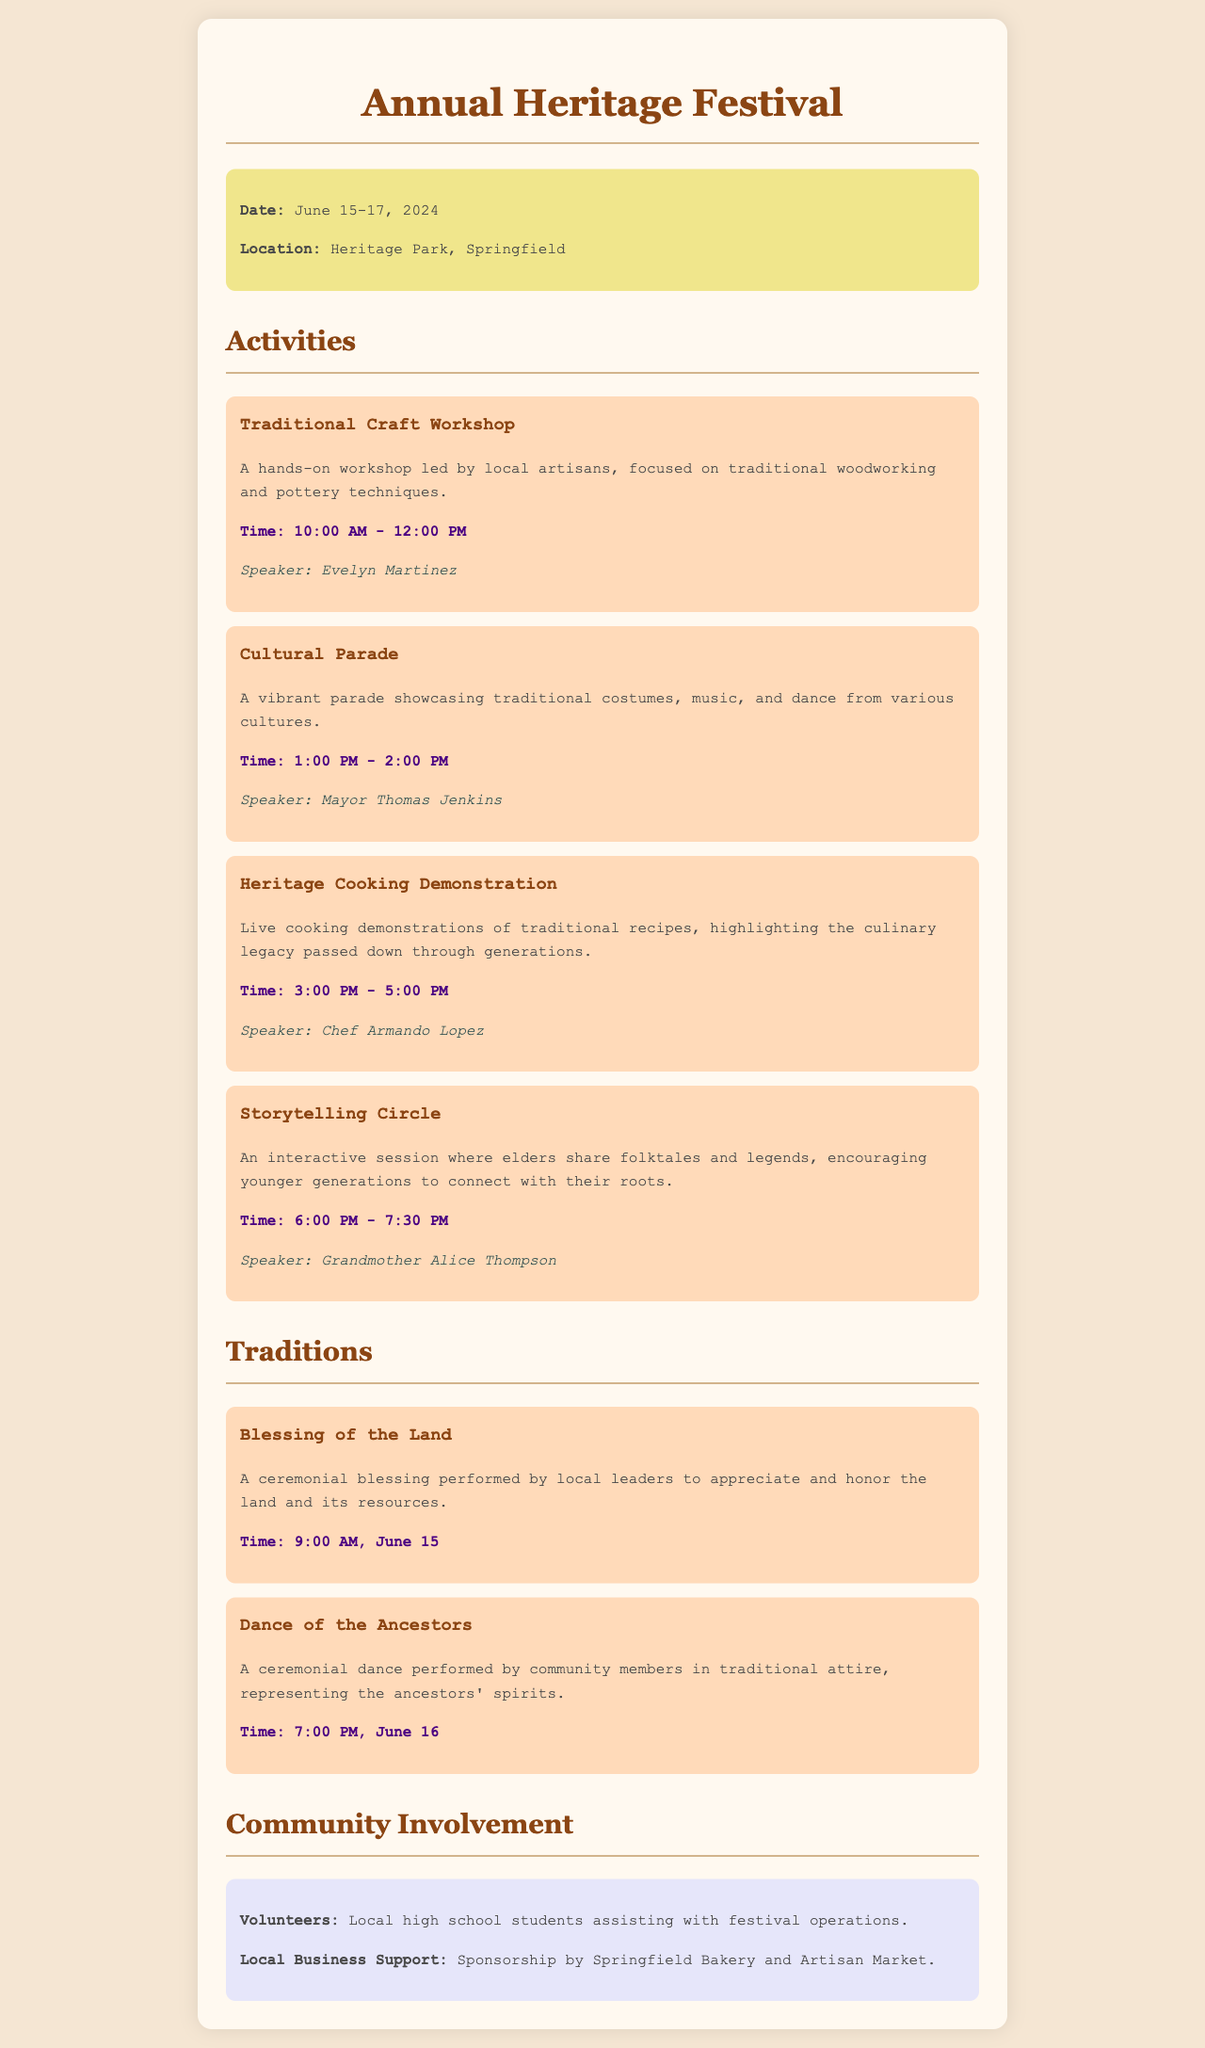what are the dates of the festival? The dates of the festival are mentioned in the document, which states it runs from June 15 to June 17, 2024.
Answer: June 15-17, 2024 where is the festival taking place? The location of the festival is specified in the event information section, stating it will be at Heritage Park, Springfield.
Answer: Heritage Park, Springfield who is leading the Traditional Craft Workshop? The document lists the speaker for the Traditional Craft Workshop as Evelyn Martinez.
Answer: Evelyn Martinez what time is the Cultural Parade scheduled? The document clearly states the time for the Cultural Parade is from 1:00 PM to 2:00 PM.
Answer: 1:00 PM - 2:00 PM what is the purpose of the Blessing of the Land? The Blessing of the Land is a ceremonial act to appreciate and honor the land and its resources, as described in the traditions section.
Answer: Appreciate and honor the land who assists with the festival operations? The document mentions that local high school students are volunteering to assist with festival operations.
Answer: Local high school students what traditional activity takes place at 7:00 PM on June 16? The Dance of the Ancestors is scheduled for 7:00 PM on June 16, as detailed in the traditions section.
Answer: Dance of the Ancestors what type of food demonstration is featured at the festival? The document highlights the Heritage Cooking Demonstration as a significant food-related activity during the festival.
Answer: Heritage Cooking Demonstration 